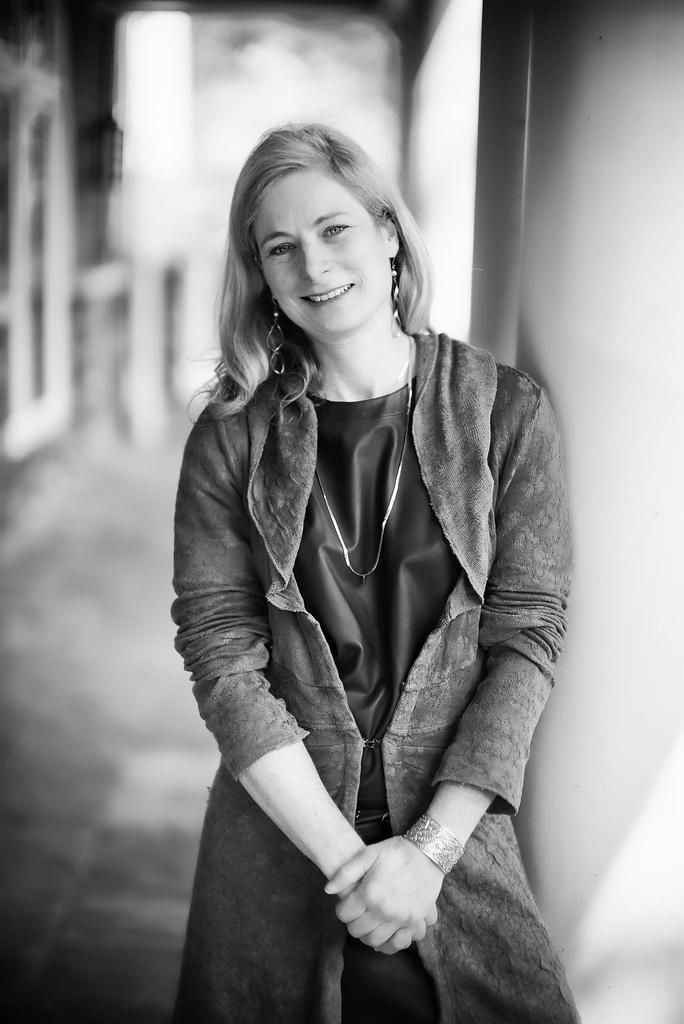What is the color scheme of the image? The image is black and white. Can you describe the person in the image? There is a lady in the image. What is the lady wearing? The lady is wearing a coat. What can be seen in the background of the image? There is a pillar in the background of the image. What type of celery can be seen in the lady's hand in the image? There is no celery present in the image; the lady is not holding any celery. How many eggs are visible on the pillar in the background? There are no eggs visible on the pillar in the background; the pillar is the only object mentioned in the background. 